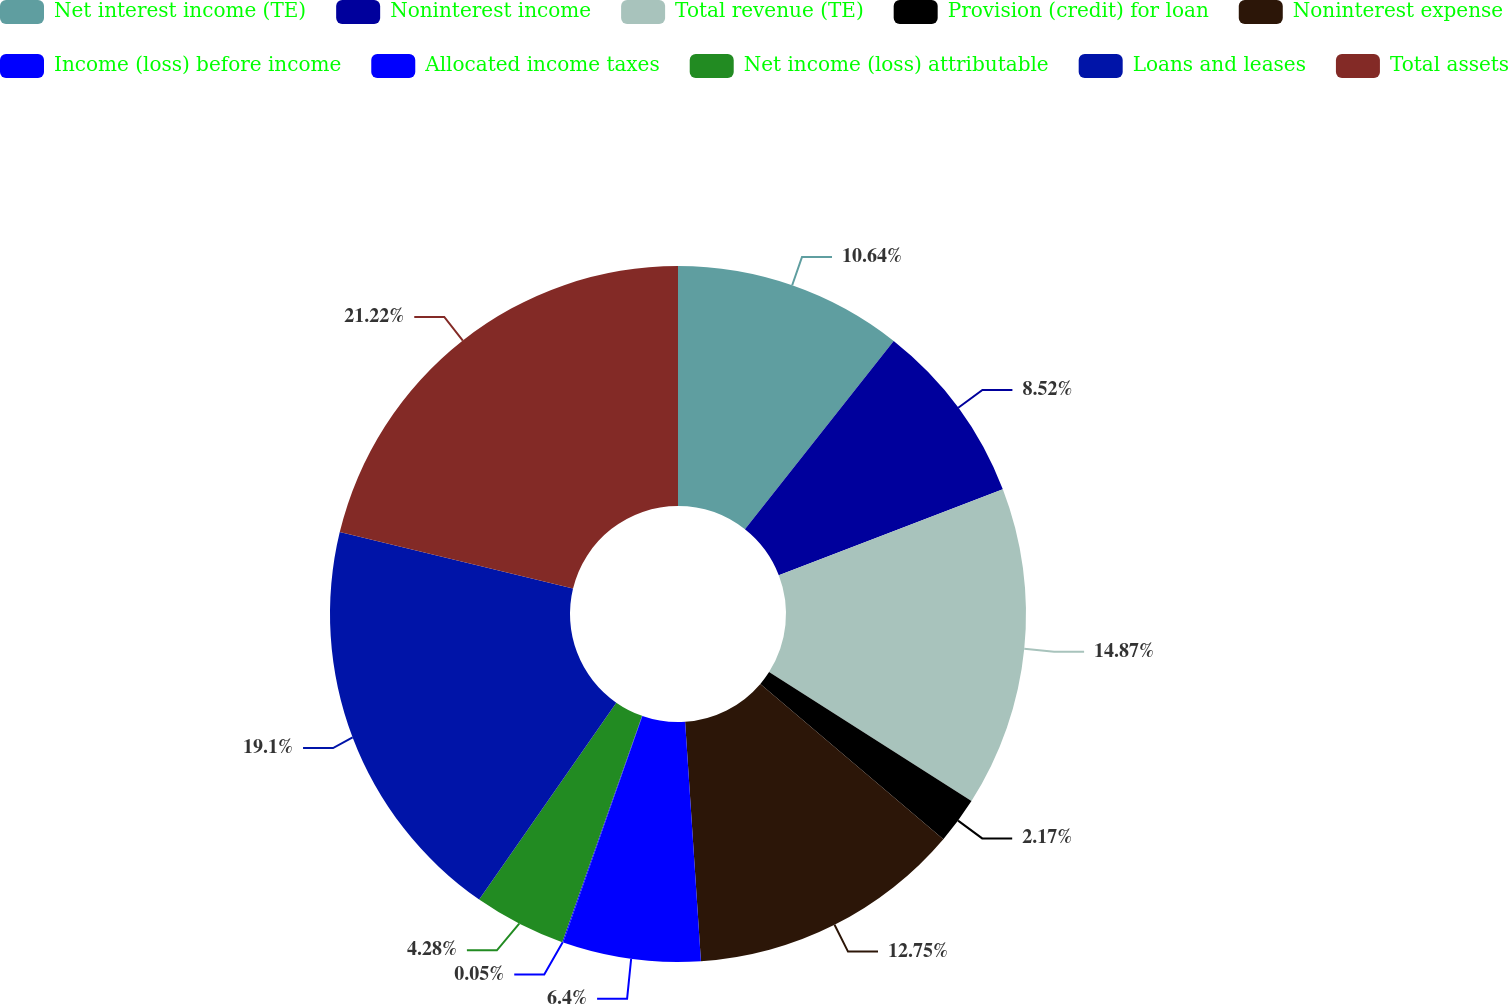Convert chart to OTSL. <chart><loc_0><loc_0><loc_500><loc_500><pie_chart><fcel>Net interest income (TE)<fcel>Noninterest income<fcel>Total revenue (TE)<fcel>Provision (credit) for loan<fcel>Noninterest expense<fcel>Income (loss) before income<fcel>Allocated income taxes<fcel>Net income (loss) attributable<fcel>Loans and leases<fcel>Total assets<nl><fcel>10.64%<fcel>8.52%<fcel>14.87%<fcel>2.17%<fcel>12.75%<fcel>6.4%<fcel>0.05%<fcel>4.28%<fcel>19.1%<fcel>21.22%<nl></chart> 